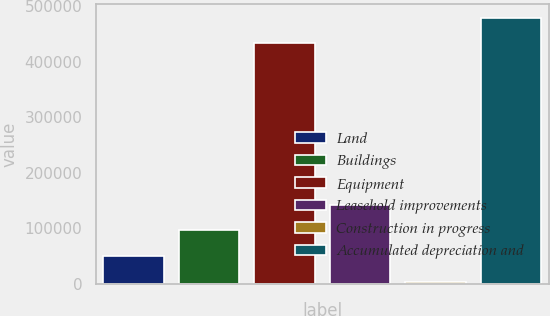Convert chart to OTSL. <chart><loc_0><loc_0><loc_500><loc_500><bar_chart><fcel>Land<fcel>Buildings<fcel>Equipment<fcel>Leasehold improvements<fcel>Construction in progress<fcel>Accumulated depreciation and<nl><fcel>49920.9<fcel>96271.8<fcel>433395<fcel>142623<fcel>3570<fcel>479746<nl></chart> 